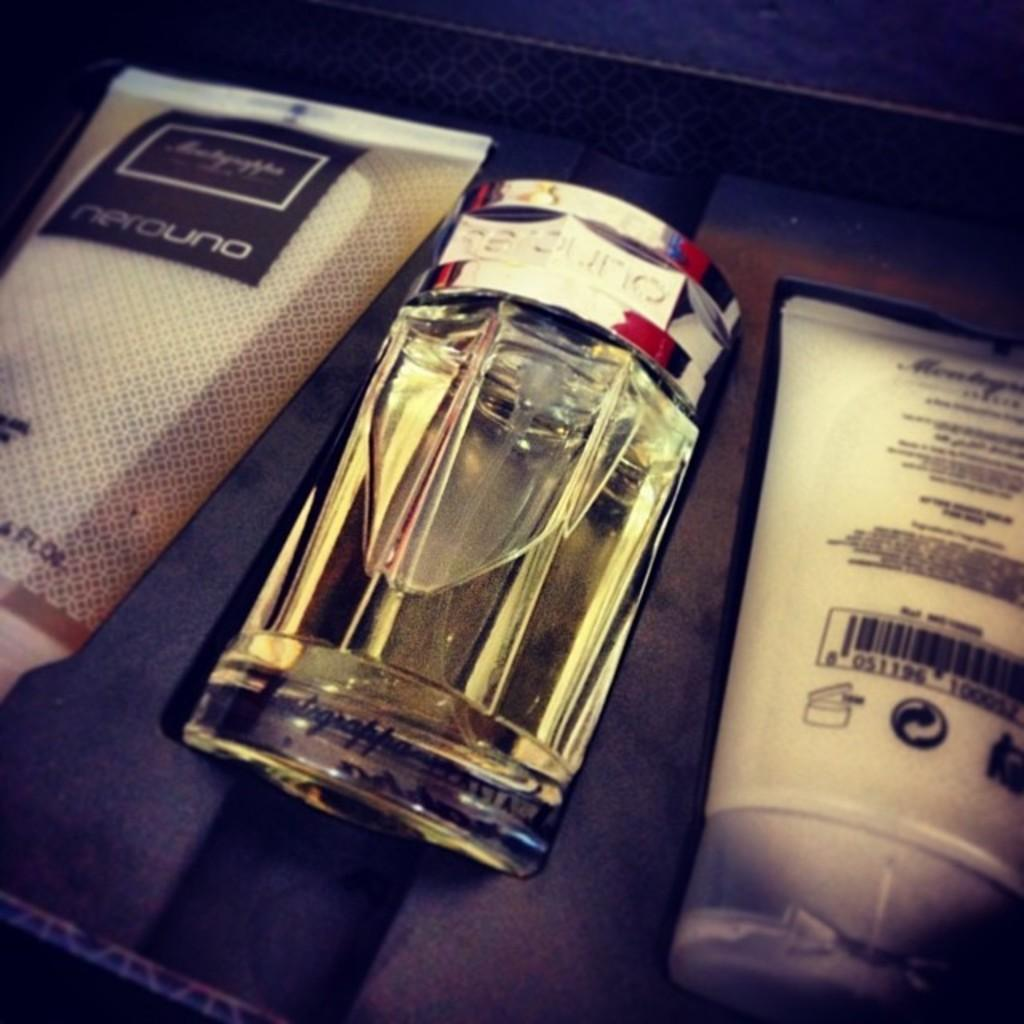<image>
Present a compact description of the photo's key features. A bottle of perfume sits next to a tube of lotion called Nerouno 